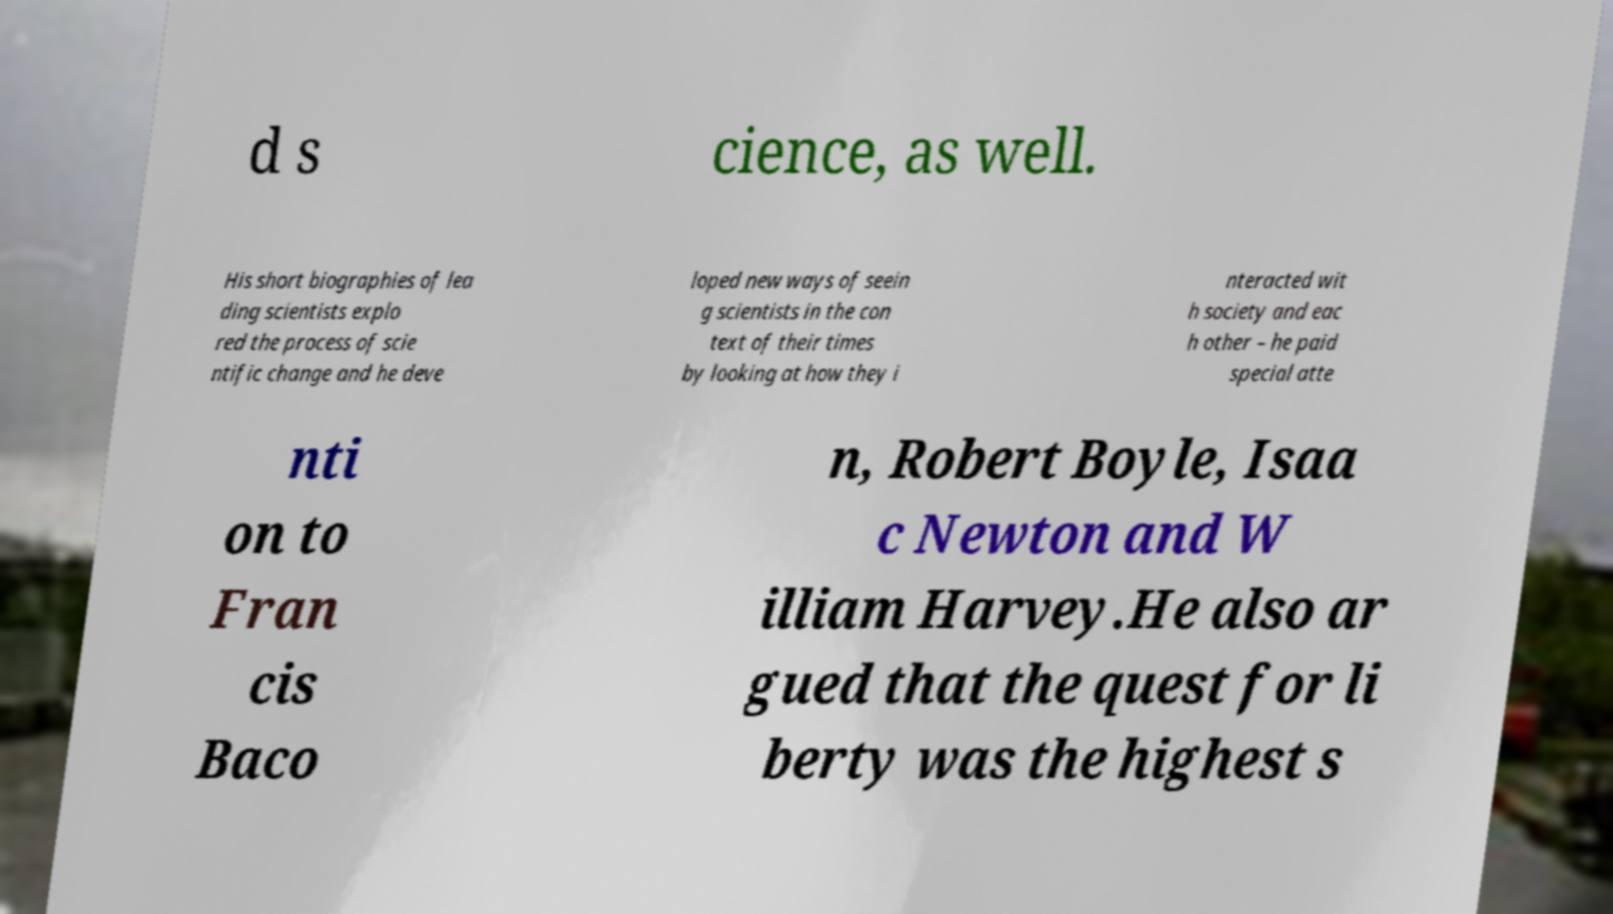There's text embedded in this image that I need extracted. Can you transcribe it verbatim? d s cience, as well. His short biographies of lea ding scientists explo red the process of scie ntific change and he deve loped new ways of seein g scientists in the con text of their times by looking at how they i nteracted wit h society and eac h other – he paid special atte nti on to Fran cis Baco n, Robert Boyle, Isaa c Newton and W illiam Harvey.He also ar gued that the quest for li berty was the highest s 